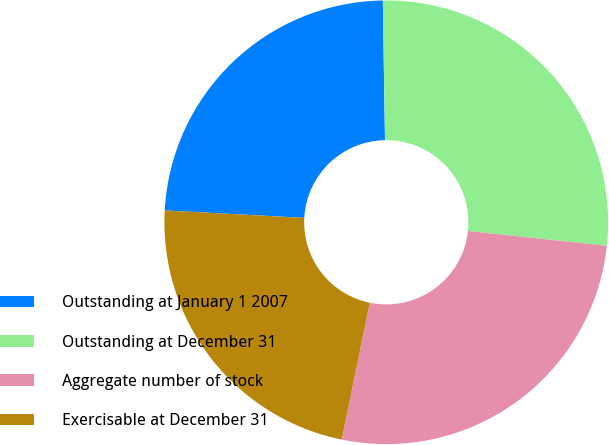Convert chart to OTSL. <chart><loc_0><loc_0><loc_500><loc_500><pie_chart><fcel>Outstanding at January 1 2007<fcel>Outstanding at December 31<fcel>Aggregate number of stock<fcel>Exercisable at December 31<nl><fcel>23.9%<fcel>26.94%<fcel>26.53%<fcel>22.63%<nl></chart> 